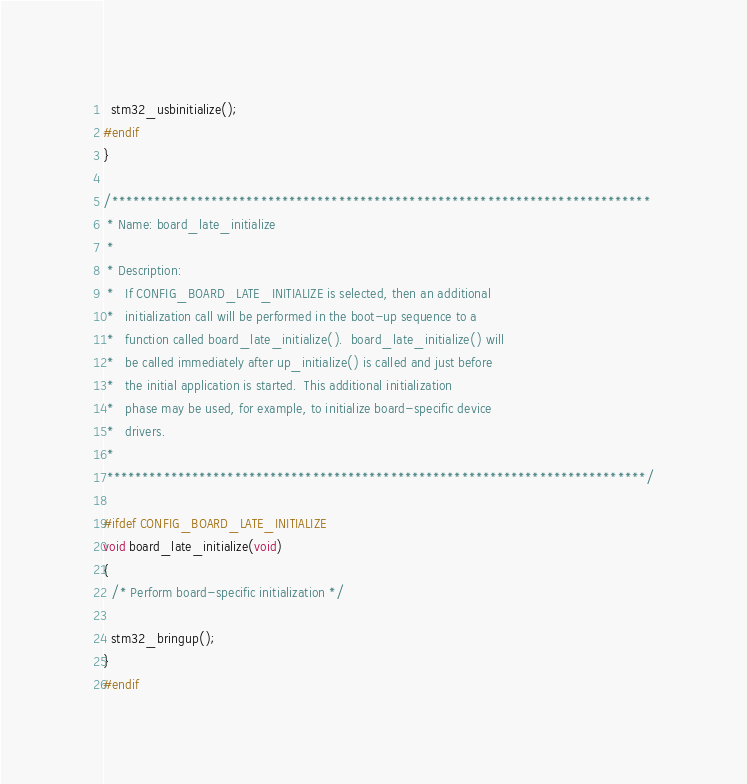Convert code to text. <code><loc_0><loc_0><loc_500><loc_500><_C_>  stm32_usbinitialize();
#endif
}

/****************************************************************************
 * Name: board_late_initialize
 *
 * Description:
 *   If CONFIG_BOARD_LATE_INITIALIZE is selected, then an additional
 *   initialization call will be performed in the boot-up sequence to a
 *   function called board_late_initialize().  board_late_initialize() will
 *   be called immediately after up_initialize() is called and just before
 *   the initial application is started.  This additional initialization
 *   phase may be used, for example, to initialize board-specific device
 *   drivers.
 *
 ****************************************************************************/

#ifdef CONFIG_BOARD_LATE_INITIALIZE
void board_late_initialize(void)
{
  /* Perform board-specific initialization */

  stm32_bringup();
}
#endif
</code> 